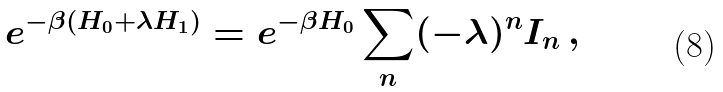Convert formula to latex. <formula><loc_0><loc_0><loc_500><loc_500>e ^ { - \beta ( H _ { 0 } + \lambda H _ { 1 } ) } = e ^ { - \beta H _ { 0 } } \sum _ { n } ( - \lambda ) ^ { n } I _ { n } \, ,</formula> 